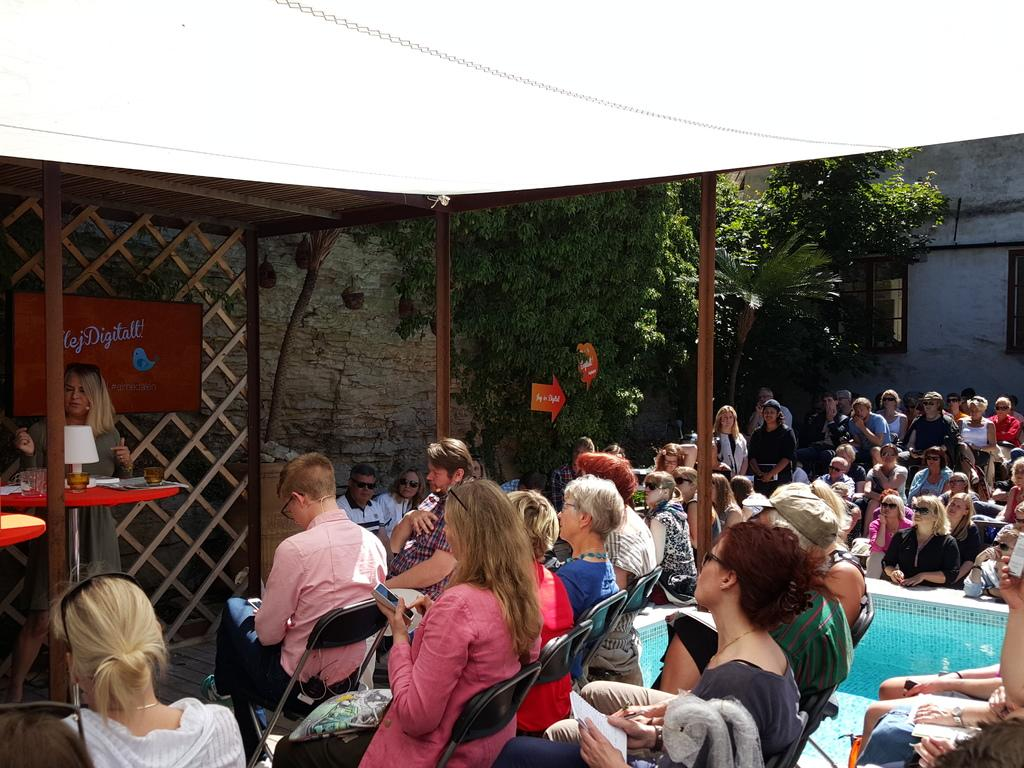What are the people in the image doing? There is a group of people standing in the image, and there are people sitting beside a pool in the image. What can be seen in the background of the image? There are trees and a wall in the background of the image. What color is the orange that the people are playing with in the image? There is no orange present in the image, and the people are not playing with any objects. 